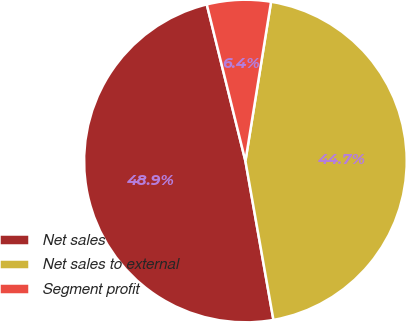Convert chart. <chart><loc_0><loc_0><loc_500><loc_500><pie_chart><fcel>Net sales<fcel>Net sales to external<fcel>Segment profit<nl><fcel>48.93%<fcel>44.68%<fcel>6.39%<nl></chart> 